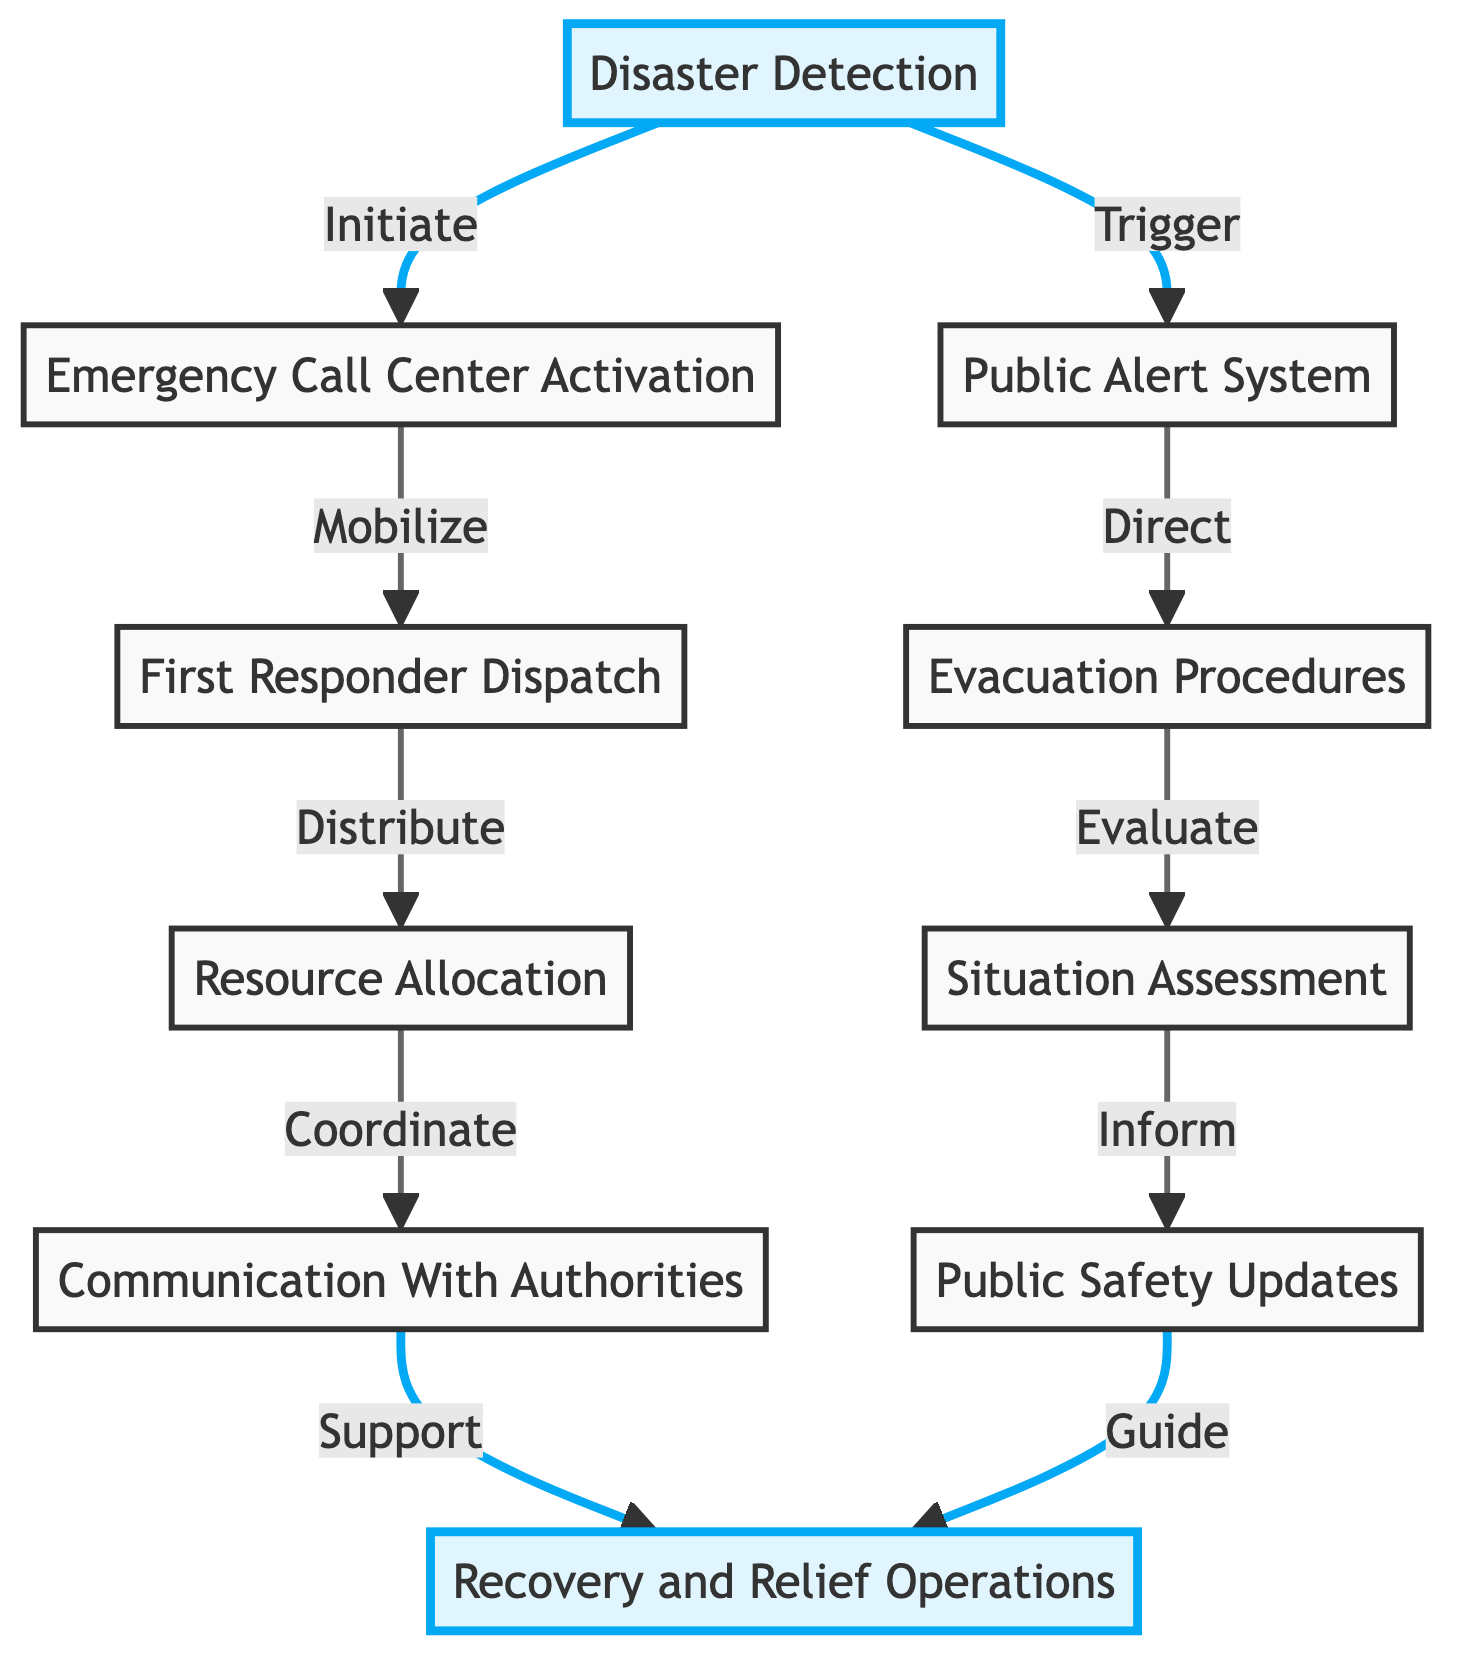What is the first step in the emergency response workflow? The diagram shows "Disaster Detection" as the initial node, which indicates it is the first step in the emergency response workflow.
Answer: Disaster Detection How many nodes are present in the diagram? By counting the nodes listed in the data, there are a total of 10 nodes illustrated in the workflow.
Answer: 10 Which node is connected to both "Emergency Call Center Activation" and "Public Alert System"? The edges indicate that "Disaster Detection" connects to both "Emergency Call Center Activation" and "Public Alert System".
Answer: Disaster Detection What follows "Evacuation Procedures" in the workflow? According to the directed edges, "Situation Assessment" directly follows after "Evacuation Procedures".
Answer: Situation Assessment How does "Resource Allocation" relate to "Communication With Authorities"? "Resource Allocation" is connected to "Communication With Authorities" through a directed edge, indicating resource distribution is coordinated with authorities.
Answer: Coordinate What is the last node in the workflow? The final node represented in the diagram is "Recovery and Relief Operations", indicating it is the last step in the emergency response sequence.
Answer: Recovery and Relief Operations How many edges are depicted in the diagram? Counting the directed edges in the data reveals there are 10 edges connecting the nodes of the workflow.
Answer: 10 Which node directly leads to "Public Safety Updates"? "Situation Assessment" and "Communication With Authorities" both lead directly to "Public Safety Updates" according to the flow structure.
Answer: Situation Assessment and Communication With Authorities What action is linked to "First Responder Dispatch"? The edge from "Emergency Call Center Activation" to "First Responder Dispatch" indicates that mobilization of first responders is an action tied to this node.
Answer: Mobilize What is the purpose of the "Public Alert System"? The description for "Public Alert System" states that its purpose is to disseminate alerts through various communication channels.
Answer: Disseminate alerts 